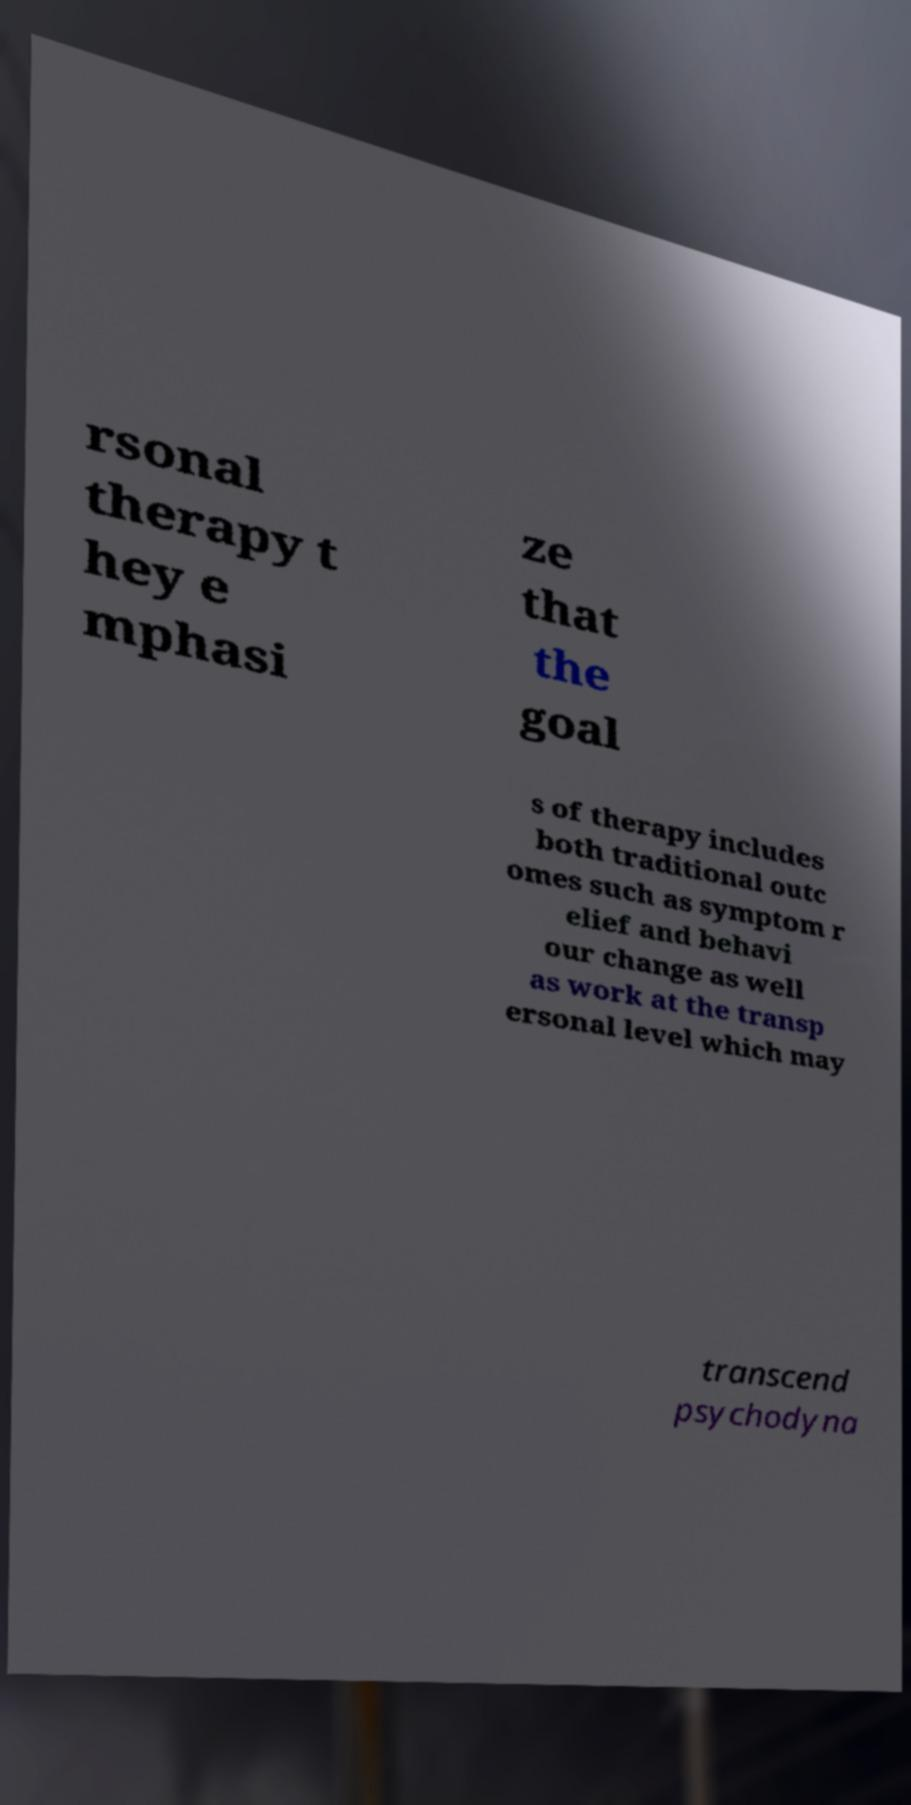I need the written content from this picture converted into text. Can you do that? rsonal therapy t hey e mphasi ze that the goal s of therapy includes both traditional outc omes such as symptom r elief and behavi our change as well as work at the transp ersonal level which may transcend psychodyna 